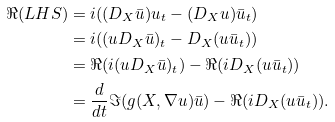<formula> <loc_0><loc_0><loc_500><loc_500>\Re ( L H S ) & = i ( ( D _ { X } \bar { u } ) u _ { t } - ( D _ { X } u ) \bar { u } _ { t } ) \\ & = i ( ( u D _ { X } \bar { u } ) _ { t } - D _ { X } ( u \bar { u } _ { t } ) ) \\ & = \Re ( i ( u D _ { X } \bar { u } ) _ { t } ) - \Re ( i D _ { X } ( u \bar { u } _ { t } ) ) \\ & = \frac { d } { d t } \Im ( g ( { X } , \nabla u ) \bar { u } ) - \Re ( i D _ { X } ( u \bar { u } _ { t } ) ) .</formula> 